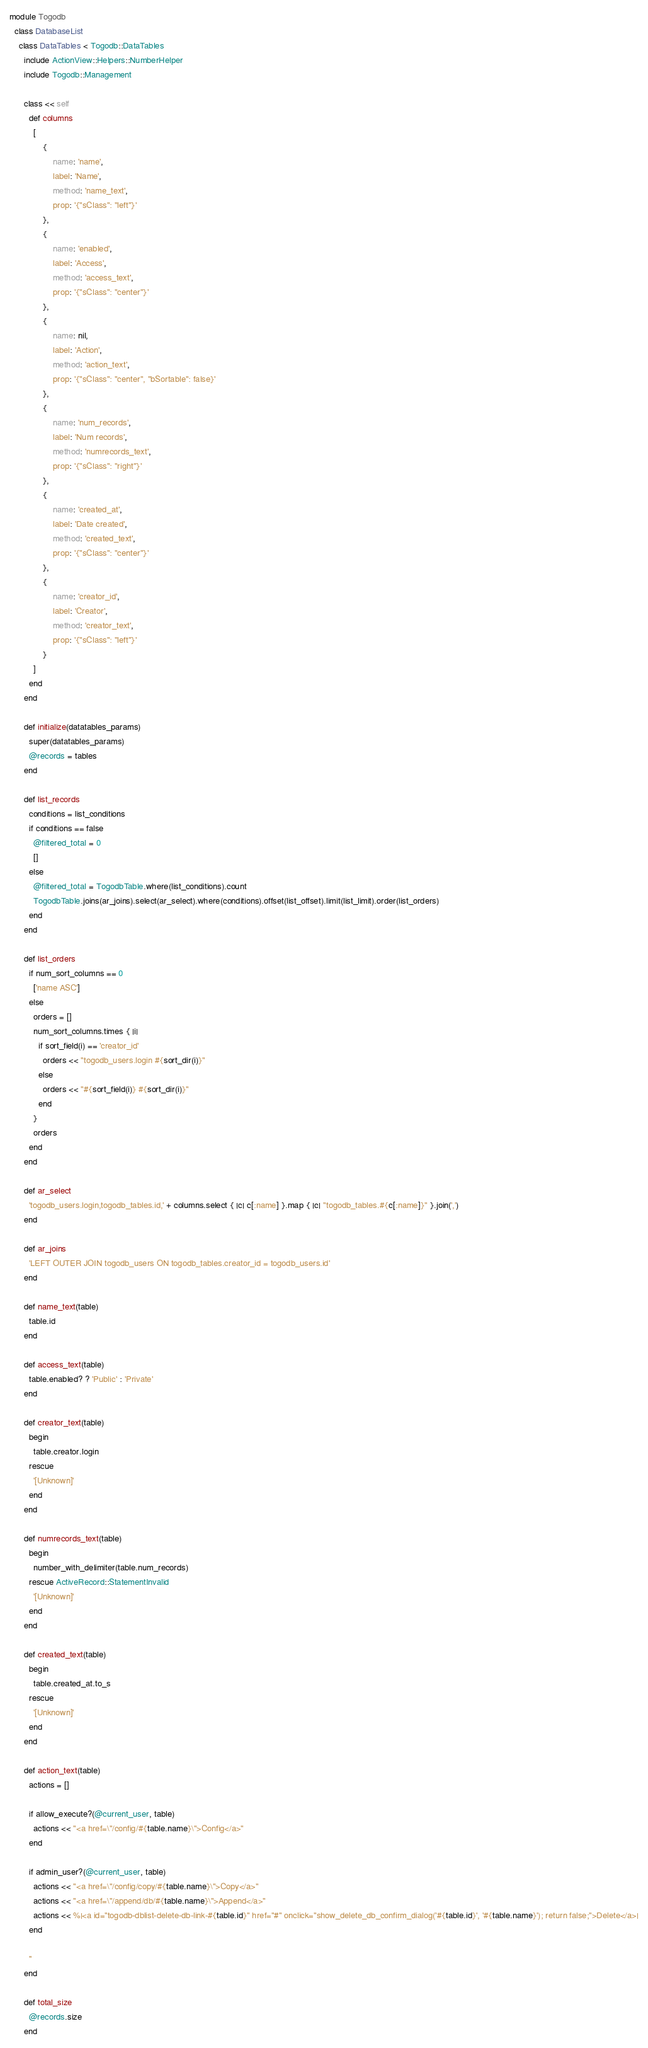Convert code to text. <code><loc_0><loc_0><loc_500><loc_500><_Ruby_>module Togodb
  class DatabaseList
    class DataTables < Togodb::DataTables
      include ActionView::Helpers::NumberHelper
      include Togodb::Management

      class << self
        def columns
          [
              {
                  name: 'name',
                  label: 'Name',
                  method: 'name_text',
                  prop: '{"sClass": "left"}'
              },
              {
                  name: 'enabled',
                  label: 'Access',
                  method: 'access_text',
                  prop: '{"sClass": "center"}'
              },
              {
                  name: nil,
                  label: 'Action',
                  method: 'action_text',
                  prop: '{"sClass": "center", "bSortable": false}'
              },
              {
                  name: 'num_records',
                  label: 'Num records',
                  method: 'numrecords_text',
                  prop: '{"sClass": "right"}'
              },
              {
                  name: 'created_at',
                  label: 'Date created',
                  method: 'created_text',
                  prop: '{"sClass": "center"}'
              },
              {
                  name: 'creator_id',
                  label: 'Creator',
                  method: 'creator_text',
                  prop: '{"sClass": "left"}'
              }
          ]
        end
      end

      def initialize(datatables_params)
        super(datatables_params)
        @records = tables
      end

      def list_records
        conditions = list_conditions
        if conditions == false
          @filtered_total = 0
          []
        else
          @filtered_total = TogodbTable.where(list_conditions).count
          TogodbTable.joins(ar_joins).select(ar_select).where(conditions).offset(list_offset).limit(list_limit).order(list_orders)
        end
      end

      def list_orders
        if num_sort_columns == 0
          ['name ASC']
        else
          orders = []
          num_sort_columns.times { |i|
            if sort_field(i) == 'creator_id'
              orders << "togodb_users.login #{sort_dir(i)}"
            else
              orders << "#{sort_field(i)} #{sort_dir(i)}"
            end
          }
          orders
        end
      end

      def ar_select
        'togodb_users.login,togodb_tables.id,' + columns.select { |c| c[:name] }.map { |c| "togodb_tables.#{c[:name]}" }.join(',')
      end

      def ar_joins
        'LEFT OUTER JOIN togodb_users ON togodb_tables.creator_id = togodb_users.id'
      end

      def name_text(table)
        table.id
      end

      def access_text(table)
        table.enabled? ? 'Public' : 'Private'
      end

      def creator_text(table)
        begin
          table.creator.login
        rescue
          '[Unknown]'
        end
      end

      def numrecords_text(table)
        begin
          number_with_delimiter(table.num_records)
        rescue ActiveRecord::StatementInvalid
          '[Unknown]'
        end
      end

      def created_text(table)
        begin
          table.created_at.to_s
        rescue
          '[Unknown]'
        end
      end

      def action_text(table)
        actions = []

        if allow_execute?(@current_user, table)
          actions << "<a href=\"/config/#{table.name}\">Config</a>"
        end

        if admin_user?(@current_user, table)
          actions << "<a href=\"/config/copy/#{table.name}\">Copy</a>"
          actions << "<a href=\"/append/db/#{table.name}\">Append</a>"
          actions << %|<a id="togodb-dblist-delete-db-link-#{table.id}" href="#" onclick="show_delete_db_confirm_dialog('#{table.id}', '#{table.name}'); return false;">Delete</a>|
        end

        ''
      end

      def total_size
        @records.size
      end
</code> 